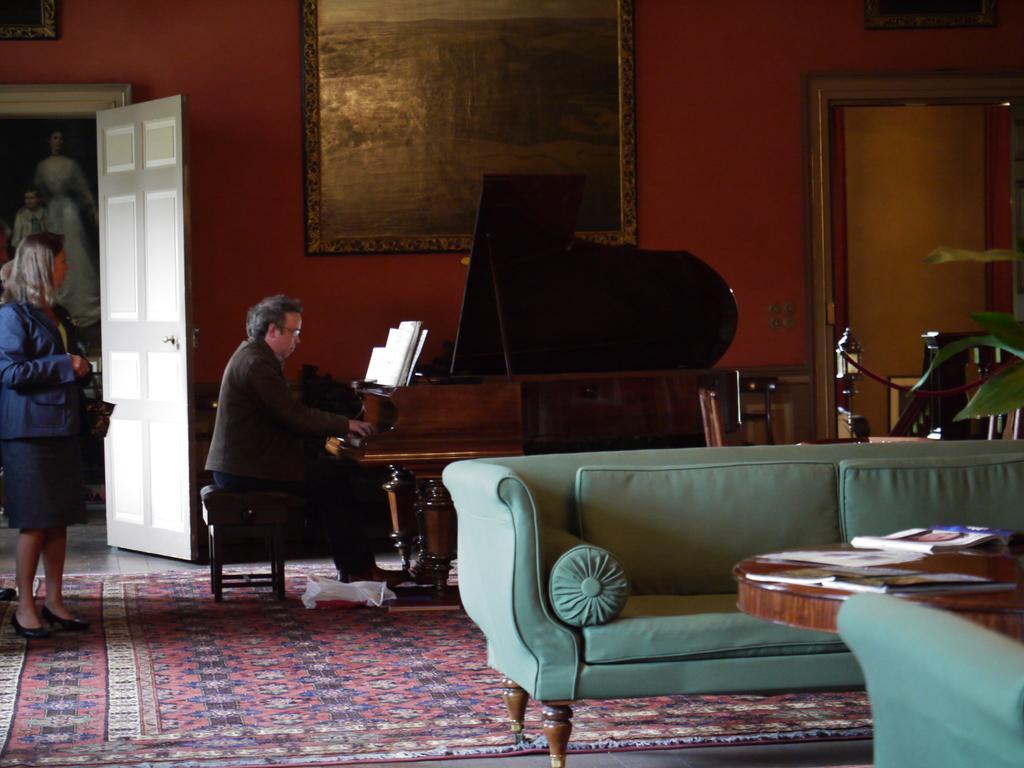Could you give a brief overview of what you see in this image? A picture is on red wall. This man is sitting in-front of this piano keyboard. On this piano keyboard there are books. A floor with carpet. Front there is a couch. In-front of this cough there is a table, on this table there are books and papers. A woman is standing and wore a blue suit. 